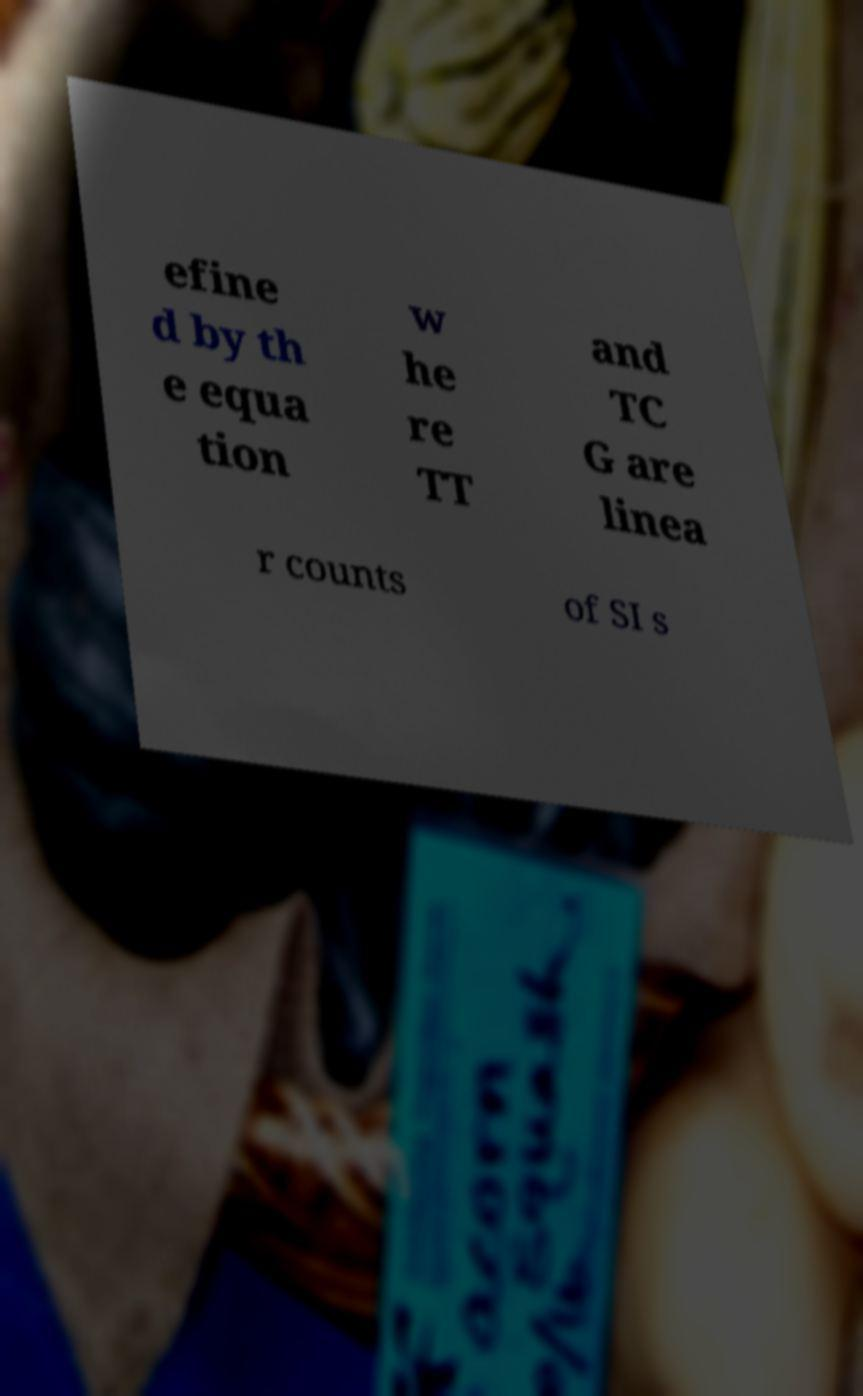For documentation purposes, I need the text within this image transcribed. Could you provide that? efine d by th e equa tion w he re TT and TC G are linea r counts of SI s 